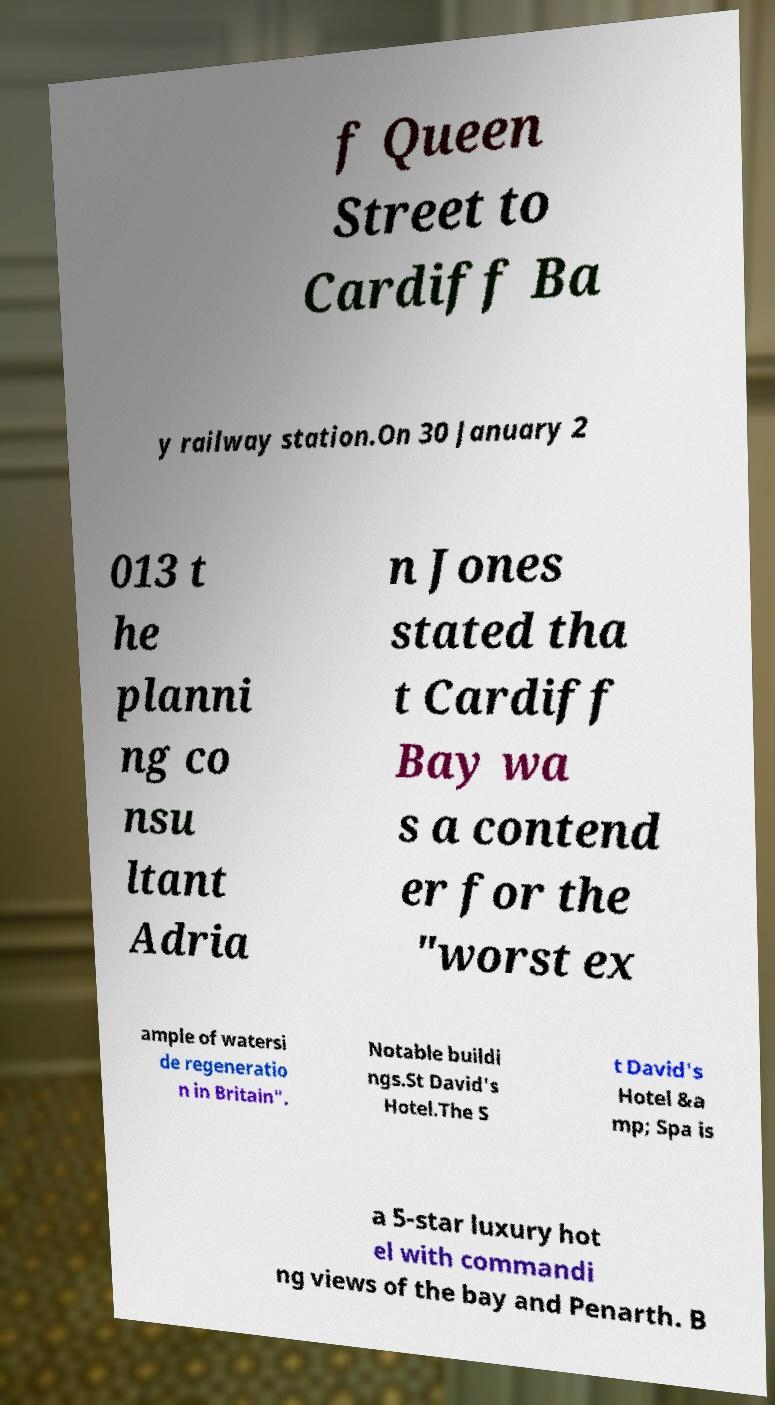Can you accurately transcribe the text from the provided image for me? f Queen Street to Cardiff Ba y railway station.On 30 January 2 013 t he planni ng co nsu ltant Adria n Jones stated tha t Cardiff Bay wa s a contend er for the "worst ex ample of watersi de regeneratio n in Britain". Notable buildi ngs.St David's Hotel.The S t David's Hotel &a mp; Spa is a 5-star luxury hot el with commandi ng views of the bay and Penarth. B 